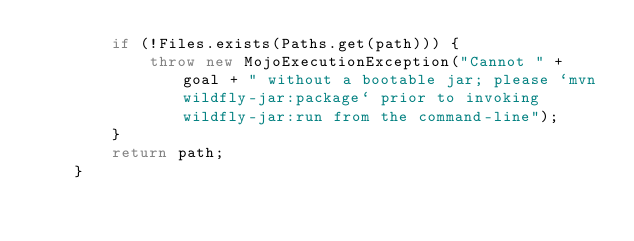<code> <loc_0><loc_0><loc_500><loc_500><_Java_>        if (!Files.exists(Paths.get(path))) {
            throw new MojoExecutionException("Cannot " + goal + " without a bootable jar; please `mvn wildfly-jar:package` prior to invoking wildfly-jar:run from the command-line");
        }
        return path;
    }
</code> 